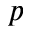<formula> <loc_0><loc_0><loc_500><loc_500>p</formula> 